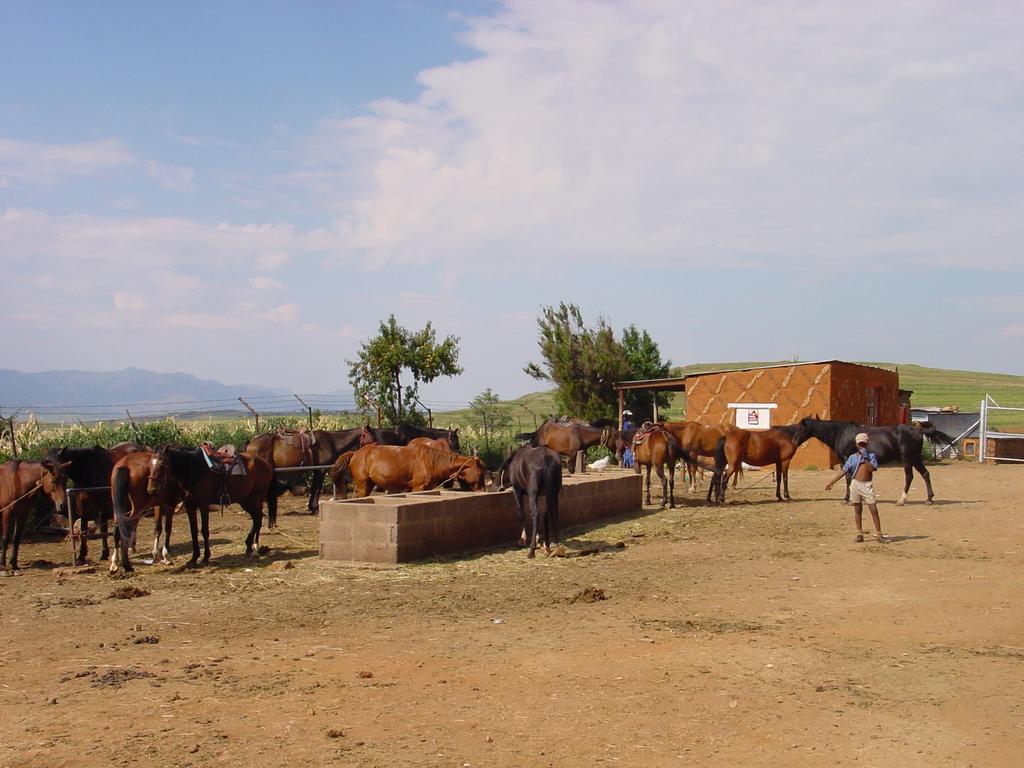Can you describe this image briefly? In this image we can see horses and a boy is standing on the ground and we can see houses, board on the wall, trees, fence, poles, grass on the ground, mountains and clouds in the sky. 